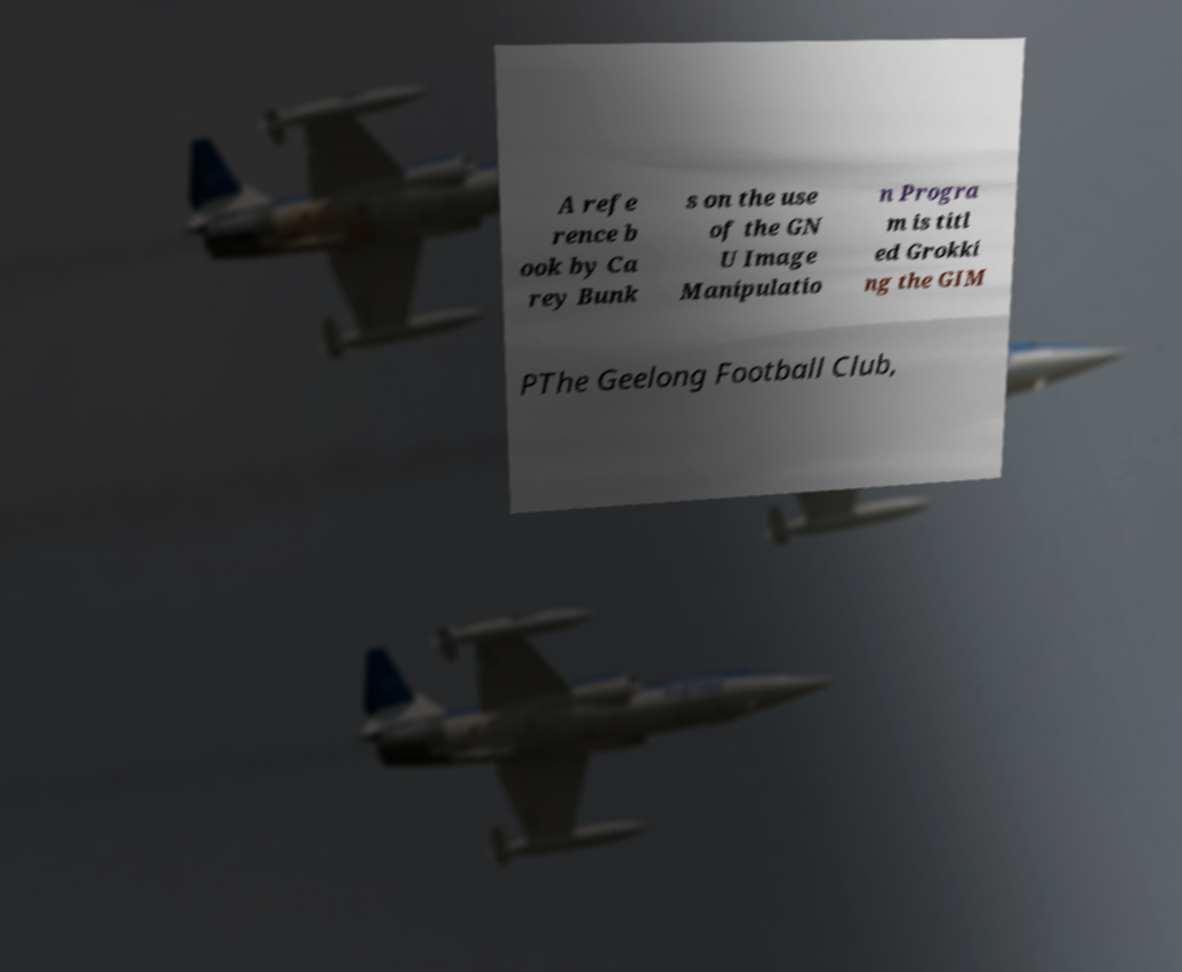Can you read and provide the text displayed in the image?This photo seems to have some interesting text. Can you extract and type it out for me? A refe rence b ook by Ca rey Bunk s on the use of the GN U Image Manipulatio n Progra m is titl ed Grokki ng the GIM PThe Geelong Football Club, 